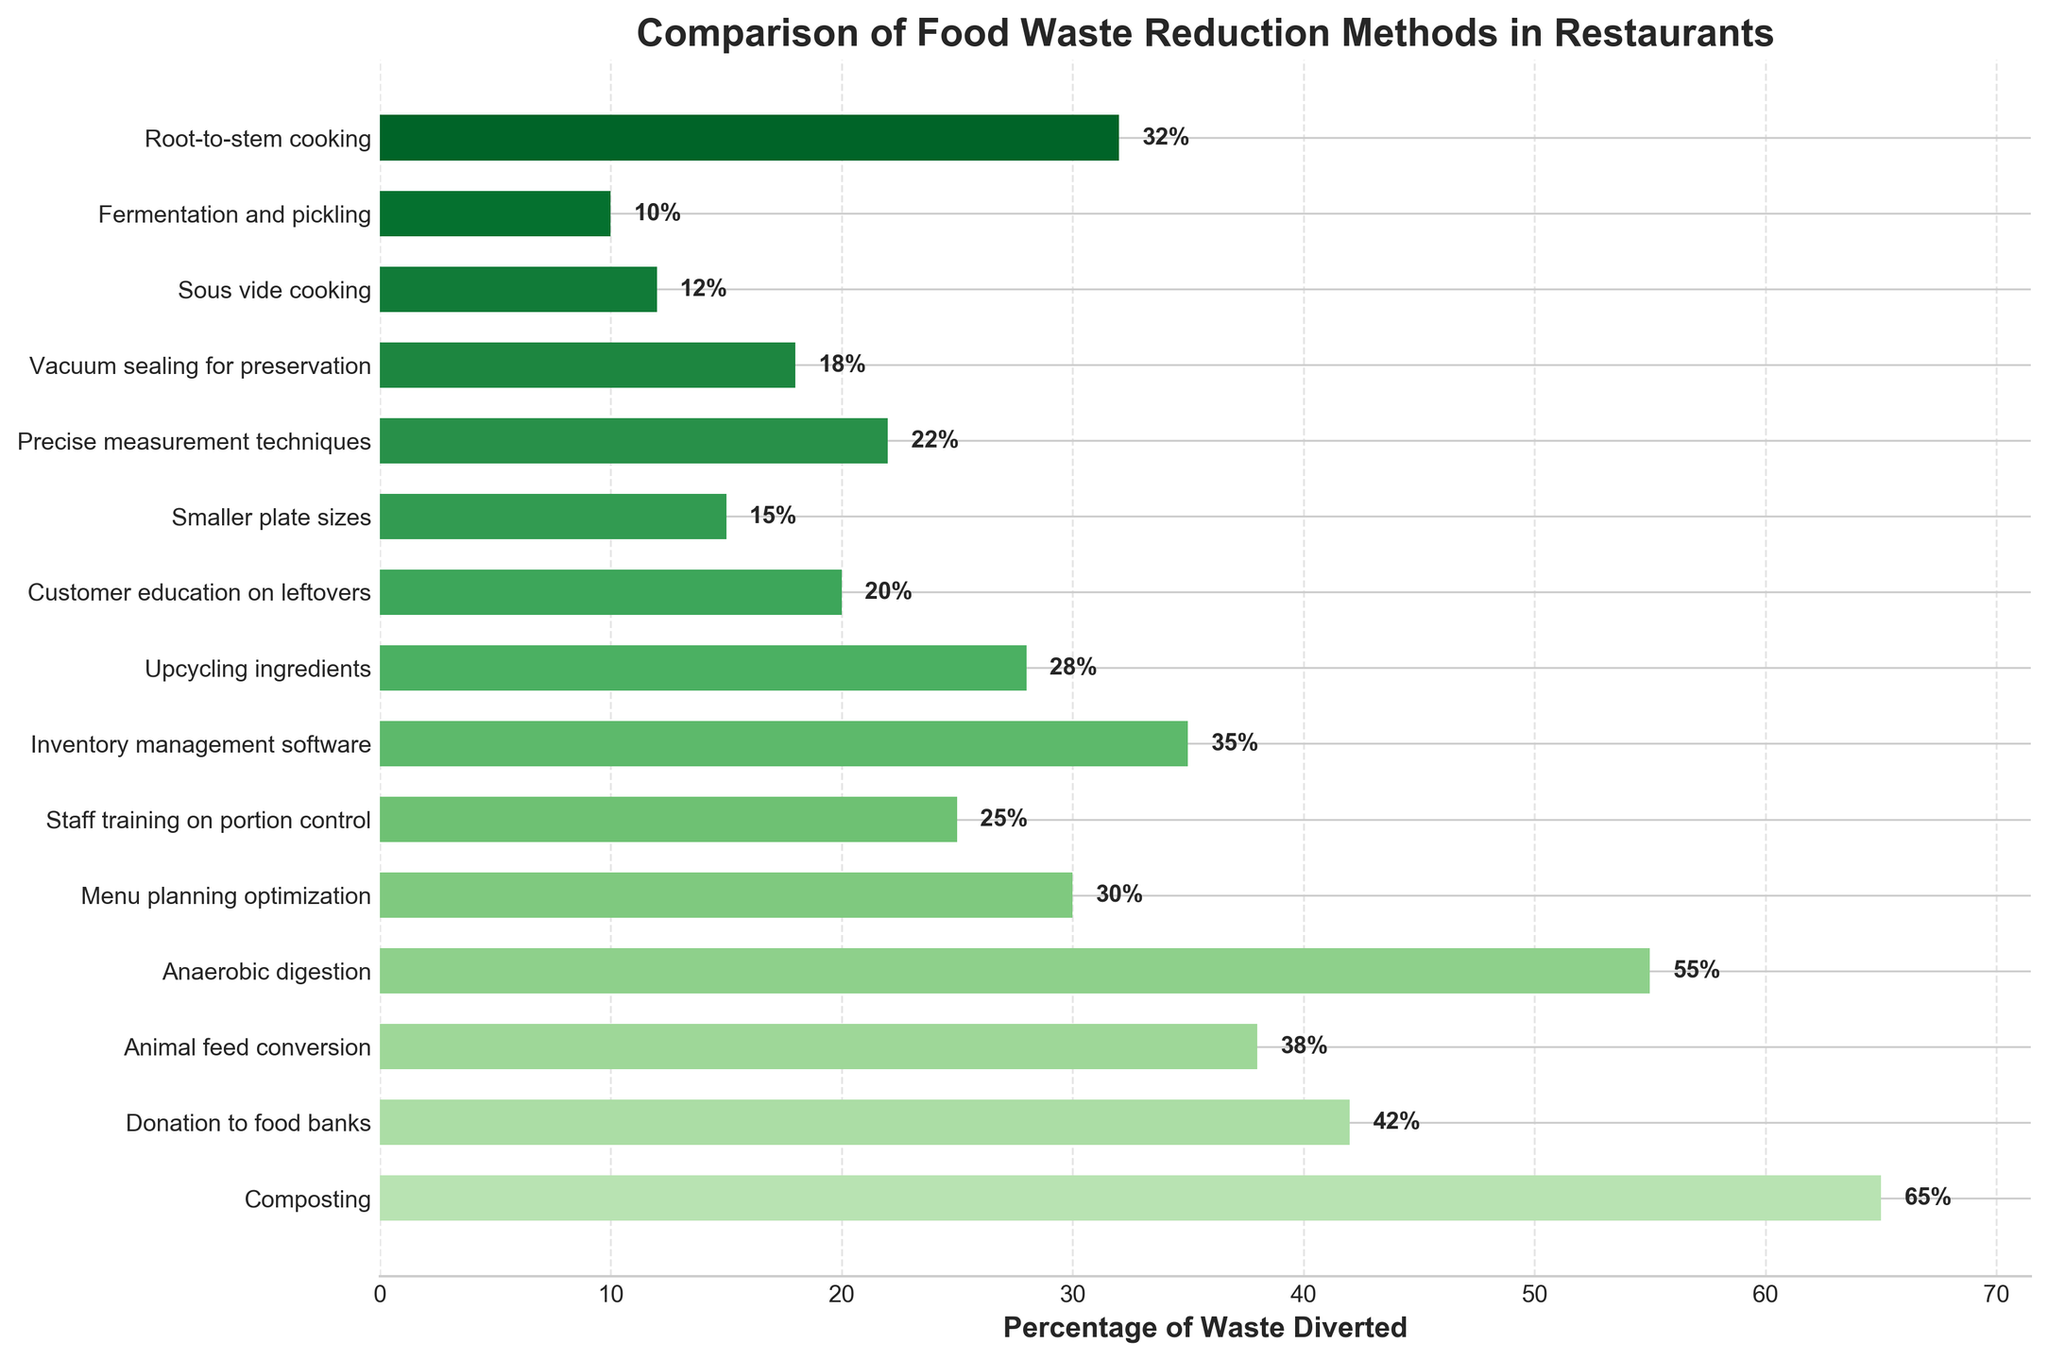Which method diverts the highest percentage of food waste? Look at the bar chart and identify the bar with the greatest length. The highest percentage of food waste diverted is associated with "Composting" at 65%.
Answer: Composting Which method diverts the least percentage of food waste? Look at the bar chart, and find the shortest bar. The method that diverts the least percentage of food waste is "Fermentation and pickling" at 10%.
Answer: Fermentation and pickling What is the difference in waste diversion percentage between staff training on portion control and composting? Find the bars corresponding to "Staff training on portion control" and "Composting." Subtract the percentage of "Staff training on portion control" (25%) from "Composting" (65%). The difference is 65% - 25% = 40%.
Answer: 40% How many methods divert more than 30% of food waste? Count all the bars whose length represents a percentage greater than 30%. The methods are "Composting," "Donation to food banks," "Animal feed conversion," "Anaerobic digestion," and "Root-to-stem cooking," totaling 5 methods.
Answer: 5 What is the average waste diversion percentage for all methods listed? Sum all the percentages and divide by the number of methods: (65 + 42 + 38 + 55 + 30 + 25 + 35 + 28 + 20 + 15 + 22 + 18 + 12 + 10 + 32) / 15. The sum is 447, so the average is 29.8%.
Answer: 29.8% Which method shows a waste diversion percentage closest to the average percentage value? The average percentage value is 29.8%. Find the method with a percentage closest to this value. "Menu planning optimization" diverts 30%, which is the closest.
Answer: Menu planning optimization Which two methods, when combined, divert more than 100% of waste? Review the bars to find combinations where their sum exceeds 100%. "Composting" (65%) + "Anaerobic digestion" (55%) equals 120%, which is more than 100%.
Answer: Composting and Anaerobic digestion Which method uses the smallest color value shade of green, and what is its percentage? In a bar chart, often lighter colors represent higher values and darker colors represent lower values. "Fermentation and pickling" uses the darkest shade because it has the smallest percentage (10%).
Answer: Fermentation and pickling, 10% Compare the waste diversion effectiveness of "Inventory management software" and "Upcycling ingredients." Which one is better, and by how much? Compare the lengths of the bars for "Inventory management software" (35%) and "Upcycling ingredients" (28%). The difference is 35% - 28% = 7%.
Answer: Inventory management software, 7% Among the methods diverting less than 20%, which one diverts the highest percentage? Identify the bars representing diversion percentages below 20% and then identify the highest among them. "Vacuum sealing for preservation" diverts 18%, which is the highest within this range.
Answer: Vacuum sealing for preservation 